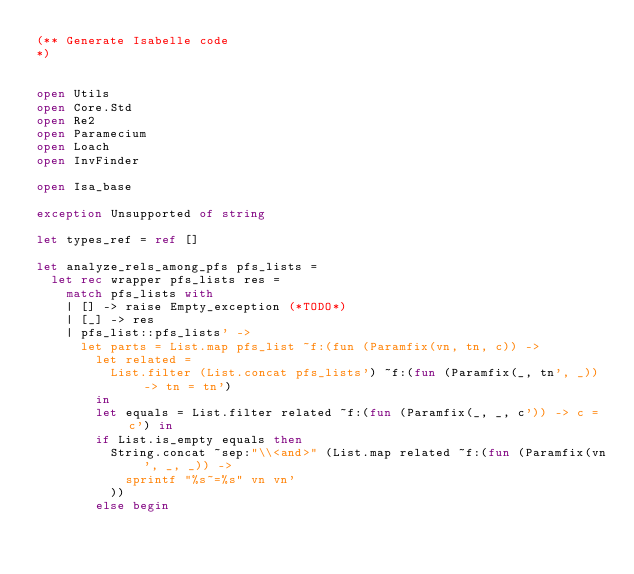<code> <loc_0><loc_0><loc_500><loc_500><_OCaml_>(** Generate Isabelle code
*)


open Utils
open Core.Std
open Re2
open Paramecium
open Loach
open InvFinder

open Isa_base

exception Unsupported of string

let types_ref = ref []

let analyze_rels_among_pfs pfs_lists =
  let rec wrapper pfs_lists res =
    match pfs_lists with
    | [] -> raise Empty_exception (*TODO*)
    | [_] -> res
    | pfs_list::pfs_lists' ->
      let parts = List.map pfs_list ~f:(fun (Paramfix(vn, tn, c)) ->
        let related =
          List.filter (List.concat pfs_lists') ~f:(fun (Paramfix(_, tn', _)) -> tn = tn')
        in
        let equals = List.filter related ~f:(fun (Paramfix(_, _, c')) -> c = c') in
        if List.is_empty equals then
          String.concat ~sep:"\\<and>" (List.map related ~f:(fun (Paramfix(vn', _, _)) ->
            sprintf "%s~=%s" vn vn'
          ))
        else begin</code> 